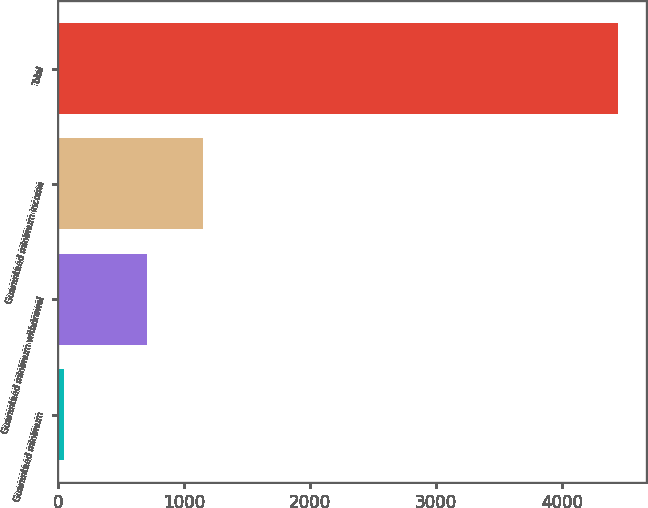Convert chart. <chart><loc_0><loc_0><loc_500><loc_500><bar_chart><fcel>Guaranteed minimum<fcel>Guaranteed minimum withdrawal<fcel>Guaranteed minimum income<fcel>Total<nl><fcel>52<fcel>710<fcel>1149.2<fcel>4444<nl></chart> 